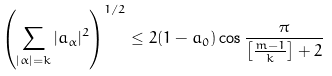<formula> <loc_0><loc_0><loc_500><loc_500>\left ( \sum _ { | \alpha | = k } | a _ { \alpha } | ^ { 2 } \right ) ^ { 1 / 2 } \leq 2 ( 1 - a _ { 0 } ) \cos \frac { \pi } { \left [ \frac { m - 1 } { k } \right ] + 2 }</formula> 